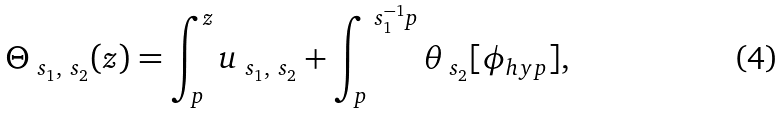<formula> <loc_0><loc_0><loc_500><loc_500>\Theta _ { \ s _ { 1 } , \ s _ { 2 } } ( z ) = \int _ { p } ^ { z } u _ { \ s _ { 1 } , \ s _ { 2 } } + \int _ { p } ^ { \ s _ { 1 } ^ { - 1 } p } \theta _ { \ s _ { 2 } } [ \phi _ { h y p } ] ,</formula> 